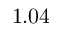<formula> <loc_0><loc_0><loc_500><loc_500>1 . 0 4</formula> 